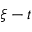Convert formula to latex. <formula><loc_0><loc_0><loc_500><loc_500>\xi - t</formula> 